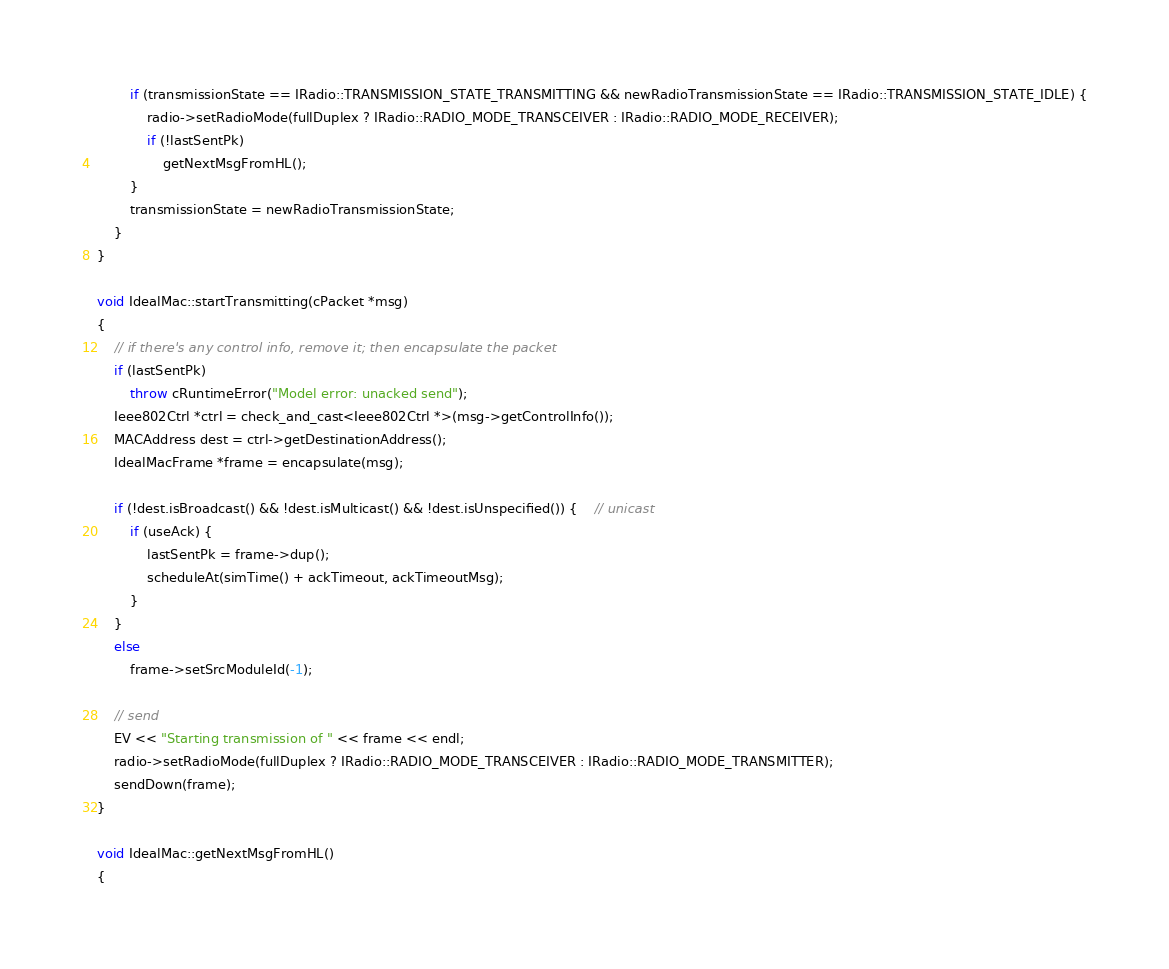Convert code to text. <code><loc_0><loc_0><loc_500><loc_500><_C++_>        if (transmissionState == IRadio::TRANSMISSION_STATE_TRANSMITTING && newRadioTransmissionState == IRadio::TRANSMISSION_STATE_IDLE) {
            radio->setRadioMode(fullDuplex ? IRadio::RADIO_MODE_TRANSCEIVER : IRadio::RADIO_MODE_RECEIVER);
            if (!lastSentPk)
                getNextMsgFromHL();
        }
        transmissionState = newRadioTransmissionState;
    }
}

void IdealMac::startTransmitting(cPacket *msg)
{
    // if there's any control info, remove it; then encapsulate the packet
    if (lastSentPk)
        throw cRuntimeError("Model error: unacked send");
    Ieee802Ctrl *ctrl = check_and_cast<Ieee802Ctrl *>(msg->getControlInfo());
    MACAddress dest = ctrl->getDestinationAddress();
    IdealMacFrame *frame = encapsulate(msg);

    if (!dest.isBroadcast() && !dest.isMulticast() && !dest.isUnspecified()) {    // unicast
        if (useAck) {
            lastSentPk = frame->dup();
            scheduleAt(simTime() + ackTimeout, ackTimeoutMsg);
        }
    }
    else
        frame->setSrcModuleId(-1);

    // send
    EV << "Starting transmission of " << frame << endl;
    radio->setRadioMode(fullDuplex ? IRadio::RADIO_MODE_TRANSCEIVER : IRadio::RADIO_MODE_TRANSMITTER);
    sendDown(frame);
}

void IdealMac::getNextMsgFromHL()
{</code> 